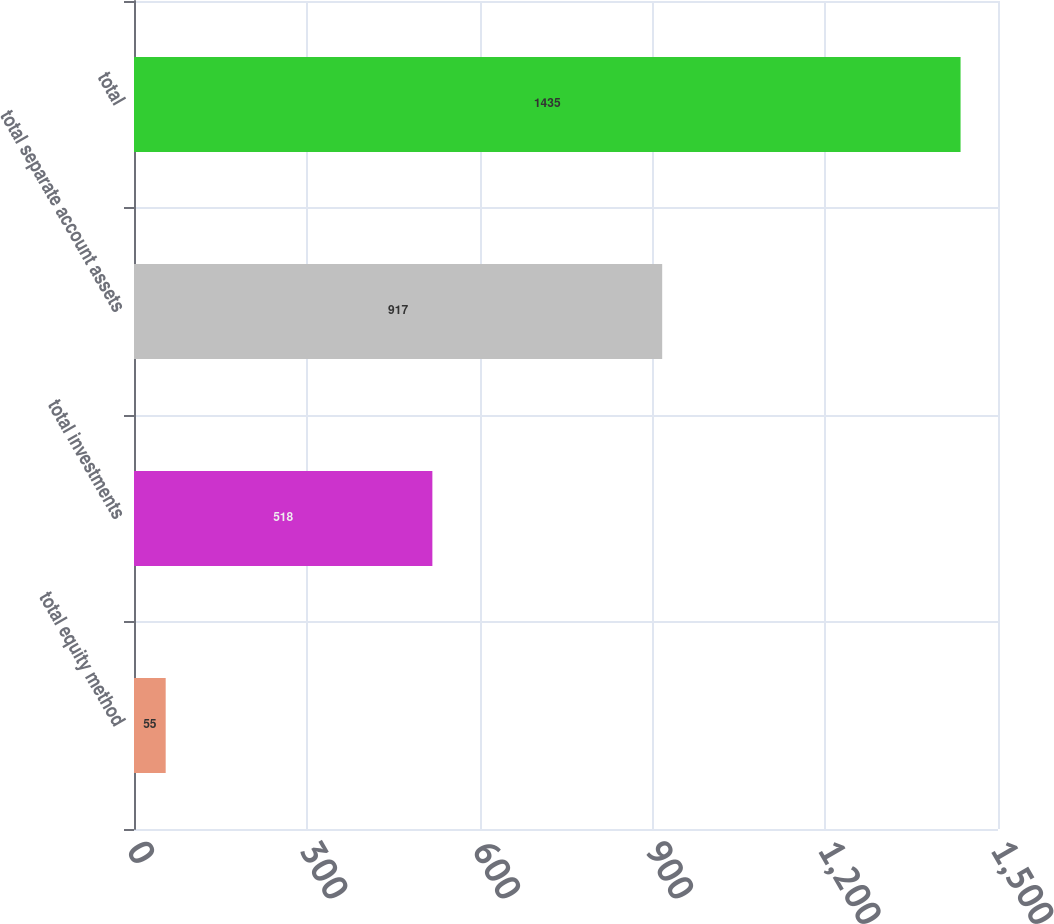Convert chart. <chart><loc_0><loc_0><loc_500><loc_500><bar_chart><fcel>total equity method<fcel>total investments<fcel>total separate account assets<fcel>total<nl><fcel>55<fcel>518<fcel>917<fcel>1435<nl></chart> 